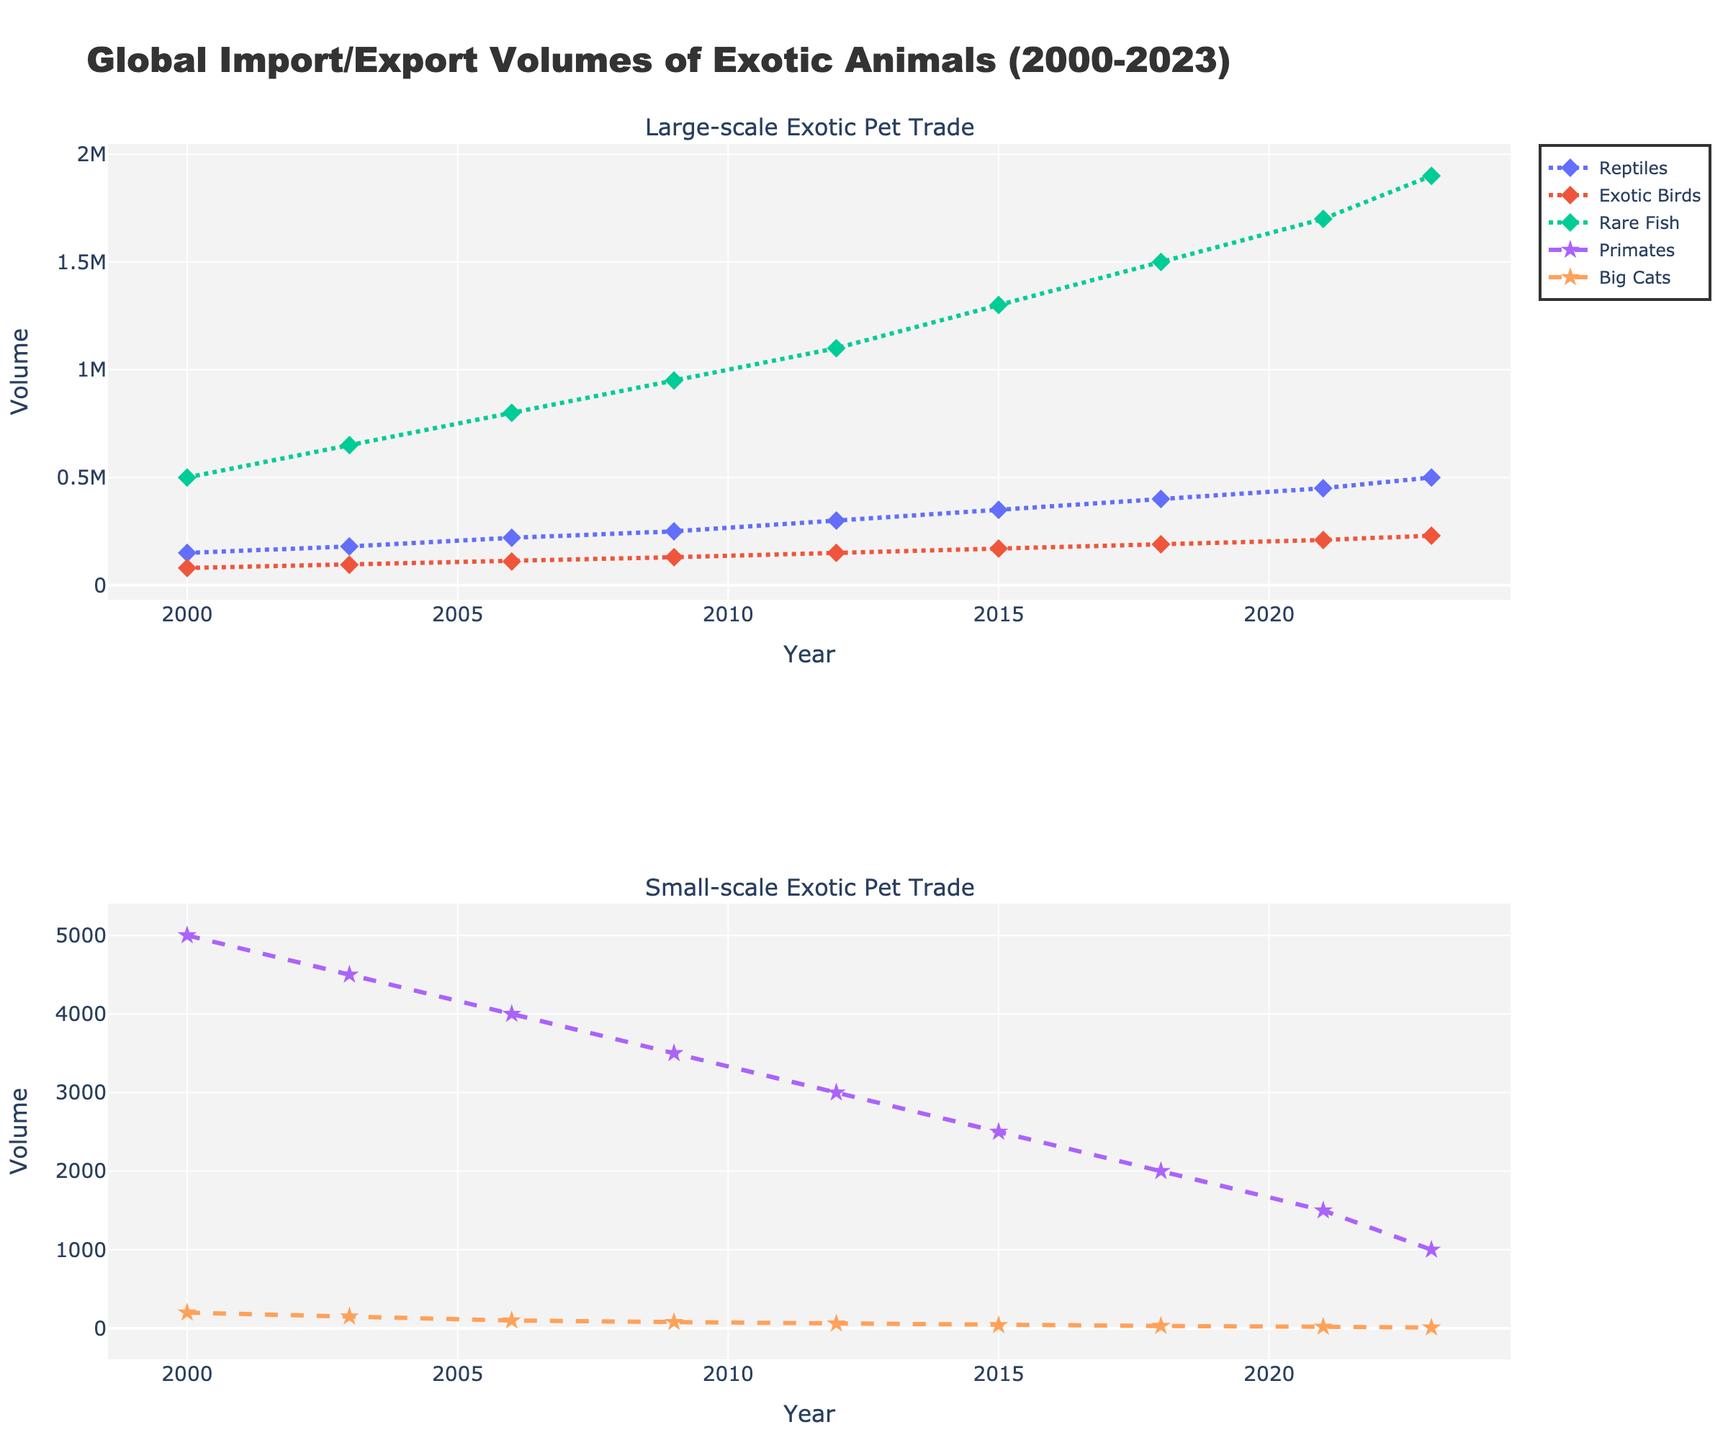What's the trend in the import/export volume of Rare Fish from 2000 to 2023? The volume of Rare Fish starts at 500,000 in 2000 and increases consistently over the years, reaching 1,900,000 in 2023. The trend shows a steady rise.
Answer: Steady increase How do the trends in Reptiles and Exotic Birds compare from 2000 to 2023? Both Reptiles and Exotic Birds exhibit an increasing trend over the years. Reptiles start at a higher volume and increase from 150,000 in 2000 to 500,000 in 2023, while Exotic Birds rise from 80,000 in 2000 to 230,000 in 2023. Both show a steady rise, with Reptiles having higher values consistently.
Answer: Both increase steadily, Reptiles have higher volumes What's the average annual import/export volume of Primates from 2000 to 2023? The volumes for Primates over the years are 5000, 4500, 4000, 3500, 3000, 2500, 2000, 1500, 1000. Summing these values gives 27000, and dividing by 9 (the number of years) gives the average: 27000 / 9 = 3000.
Answer: 3000 Which year shows the lowest volume for Big Cats and what's the value? The chart shows a decreasing trend for Big Cats, with the lowest volume of 10 in 2023.
Answer: 2023, 10 What's the combined total import/export volume of Reptiles, Exotic Birds, and Rare Fish in 2015? In 2015, the volumes are: Reptiles: 350,000, Exotic Birds: 170,000, Rare Fish: 1,300,000. Summing these values gives 350000 + 170000 + 1300000 = 1820000.
Answer: 1,820,000 How does the import/export volume for Primates change between 2000 and 2023? The volume for Primates decreases from 5000 in 2000 to 1000 in 2023, showing a consistent downward trend.
Answer: Decreases Across the timeframe, which category shows the most significant increase in volume, and by how much? Rare Fish shows the most significant increase. The volume grows from 500,000 in 2000 to 1,900,000 in 2023. The increase is 1,900,000 - 500,000 = 1,400,000.
Answer: Rare Fish, 1,400,000 Compare the trend in Rare Fish to that of Big Cats. How do their trends differ over the years? Rare Fish shows a consistent increase from 500,000 in 2000 to 1,900,000 in 2023, while Big Cats exhibit a decreasing trend from 200 in 2000 to 10 in 2023.
Answer: Rare Fish increases, Big Cats decrease What's the sum of import/export volumes for Primates and Big Cats in 2021? In 2021, the volumes are: Primates: 1500 and Big Cats: 20. The sum is 1500 + 20 = 1520.
Answer: 1520 